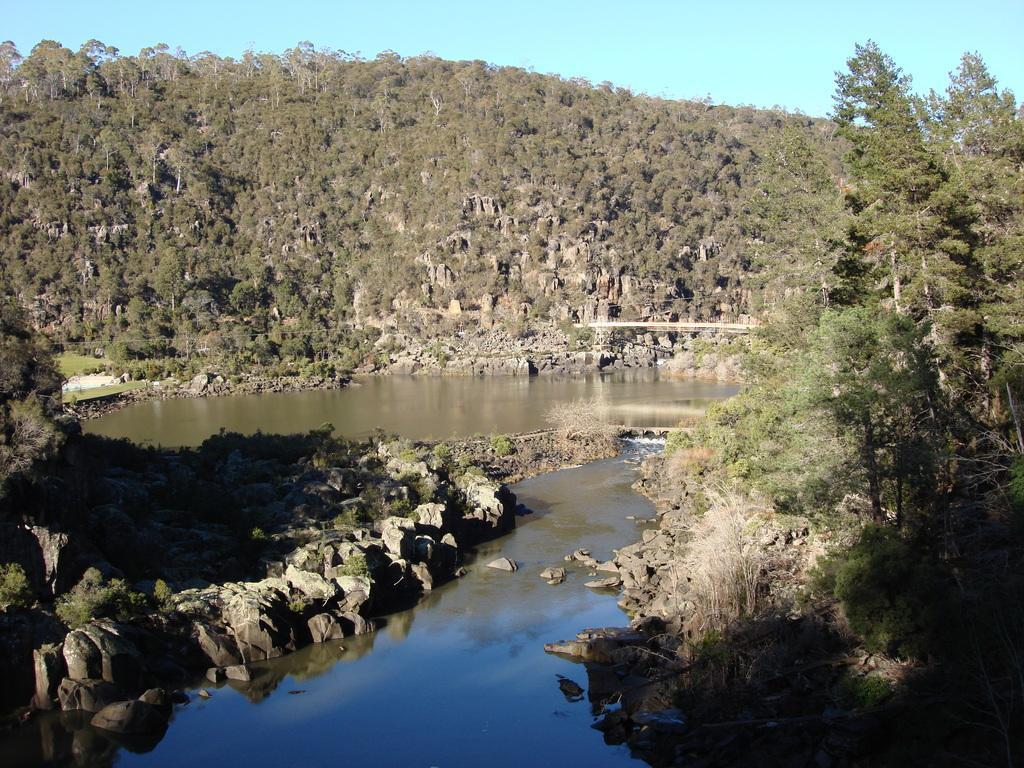Could you give a brief overview of what you see in this image? In this image, we can see a bridge and in the background, there are trees, hills. At the bottom, there is water and we can see rocks. 